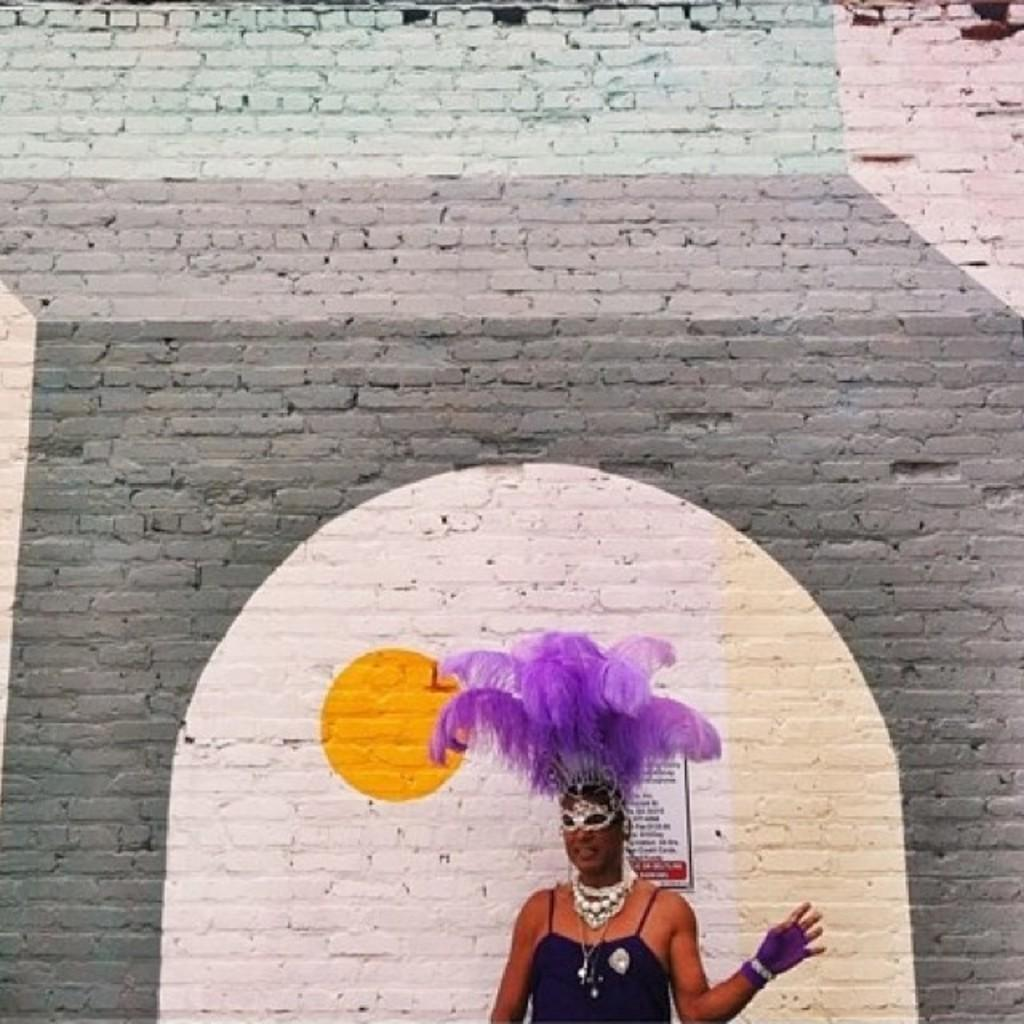What is the main subject of the image? The main subject of the image is a woman. Can you describe the woman's position in the image? The woman is standing beside a wall. How many dogs are visible in the image? There are no dogs present in the image. What type of brass object is the woman holding in the image? There is no brass object visible in the image. 